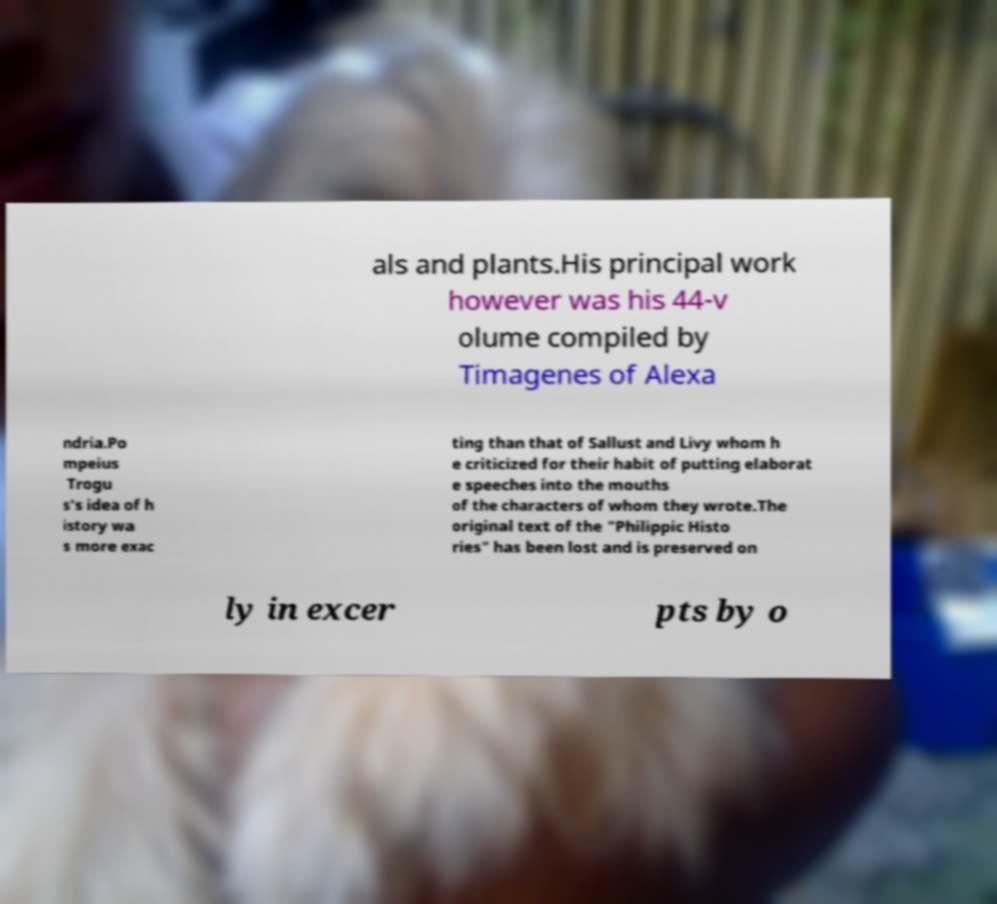Can you accurately transcribe the text from the provided image for me? als and plants.His principal work however was his 44-v olume compiled by Timagenes of Alexa ndria.Po mpeius Trogu s's idea of h istory wa s more exac ting than that of Sallust and Livy whom h e criticized for their habit of putting elaborat e speeches into the mouths of the characters of whom they wrote.The original text of the "Philippic Histo ries" has been lost and is preserved on ly in excer pts by o 